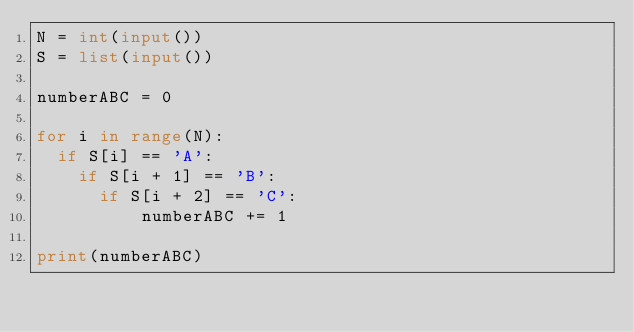Convert code to text. <code><loc_0><loc_0><loc_500><loc_500><_Python_>N = int(input())
S = list(input())
  
numberABC = 0

for i in range(N):
  if S[i] == 'A':
    if S[i + 1] == 'B':
      if S[i + 2] == 'C':
          numberABC += 1
      
print(numberABC)

</code> 